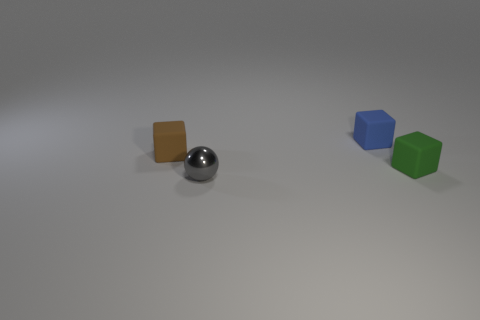There is a object that is on the left side of the small gray thing; does it have the same shape as the object in front of the tiny green object?
Give a very brief answer. No. What color is the small block that is behind the matte block left of the gray metallic sphere on the left side of the blue matte block?
Offer a very short reply. Blue. The rubber cube that is behind the small brown cube is what color?
Your answer should be compact. Blue. What color is the metallic ball that is the same size as the brown block?
Ensure brevity in your answer.  Gray. Is the blue rubber cube the same size as the brown cube?
Keep it short and to the point. Yes. How many things are on the left side of the tiny shiny thing?
Provide a succinct answer. 1. What number of objects are blocks behind the green block or large gray cubes?
Offer a terse response. 2. Are there more blue cubes left of the shiny ball than tiny objects that are to the left of the blue rubber cube?
Keep it short and to the point. No. There is a green matte cube; is its size the same as the matte cube that is on the left side of the blue object?
Provide a short and direct response. Yes. What number of cylinders are tiny rubber objects or blue objects?
Your response must be concise. 0. 